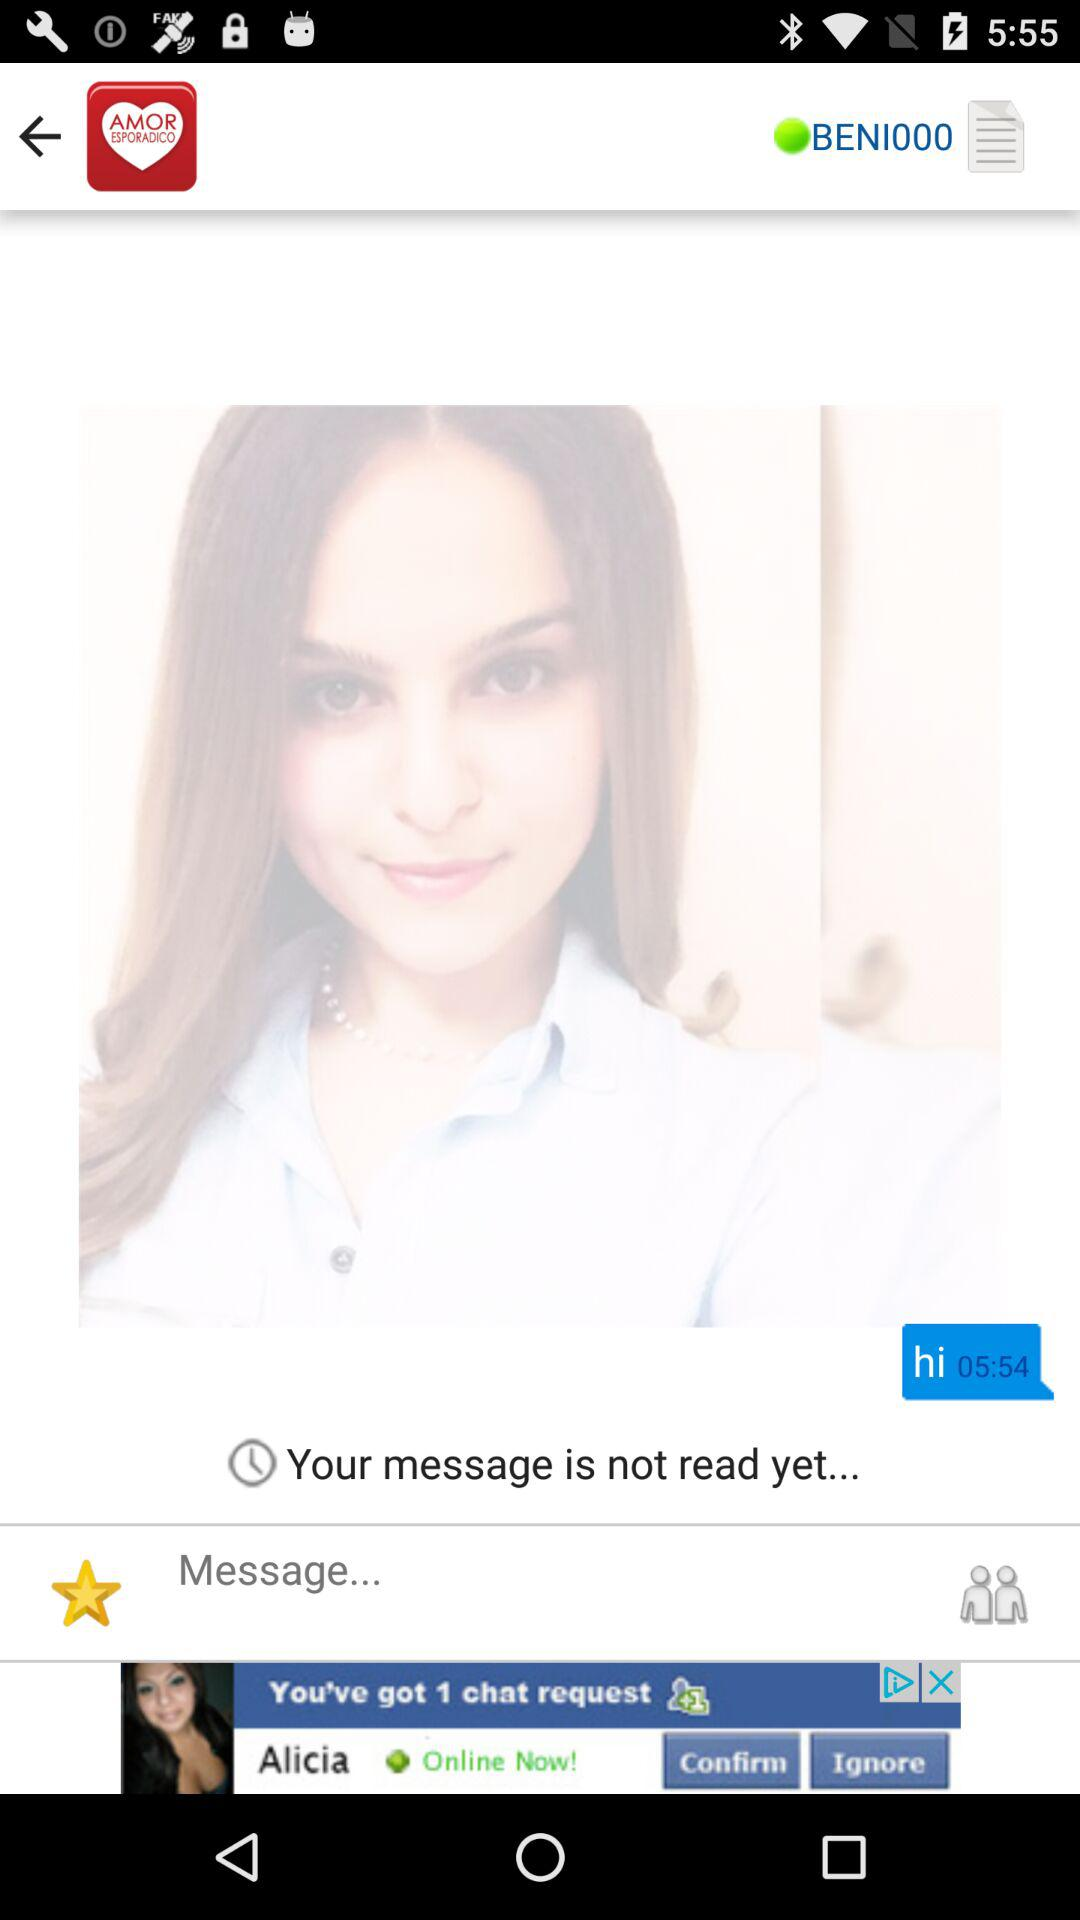At what time is the message received? The message was received at 05:54. 